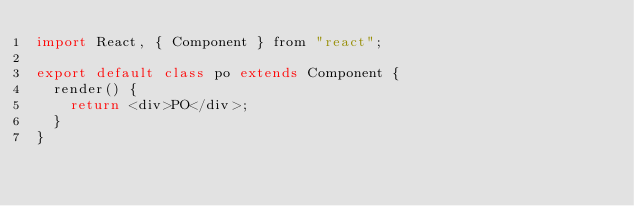<code> <loc_0><loc_0><loc_500><loc_500><_JavaScript_>import React, { Component } from "react";

export default class po extends Component {
  render() {
    return <div>PO</div>;
  }
}
</code> 